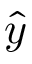Convert formula to latex. <formula><loc_0><loc_0><loc_500><loc_500>\hat { y }</formula> 